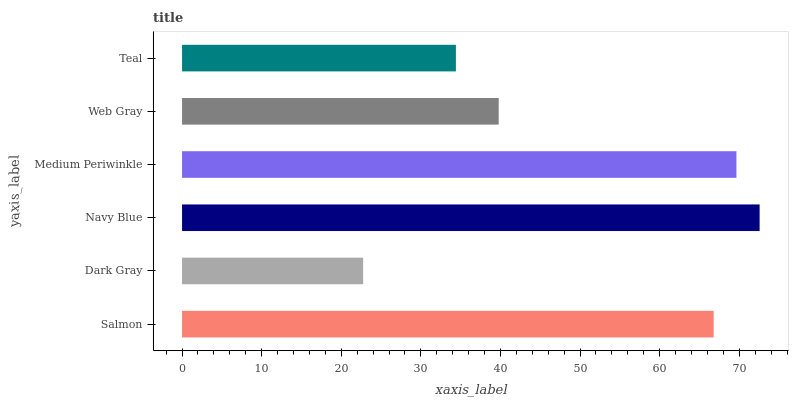Is Dark Gray the minimum?
Answer yes or no. Yes. Is Navy Blue the maximum?
Answer yes or no. Yes. Is Navy Blue the minimum?
Answer yes or no. No. Is Dark Gray the maximum?
Answer yes or no. No. Is Navy Blue greater than Dark Gray?
Answer yes or no. Yes. Is Dark Gray less than Navy Blue?
Answer yes or no. Yes. Is Dark Gray greater than Navy Blue?
Answer yes or no. No. Is Navy Blue less than Dark Gray?
Answer yes or no. No. Is Salmon the high median?
Answer yes or no. Yes. Is Web Gray the low median?
Answer yes or no. Yes. Is Web Gray the high median?
Answer yes or no. No. Is Dark Gray the low median?
Answer yes or no. No. 